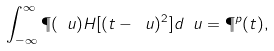Convert formula to latex. <formula><loc_0><loc_0><loc_500><loc_500>\int _ { - \infty } ^ { \infty } \P ( \ u ) H [ ( t - \ u ) ^ { 2 } ] d \ u = \P ^ { p } ( t ) ,</formula> 